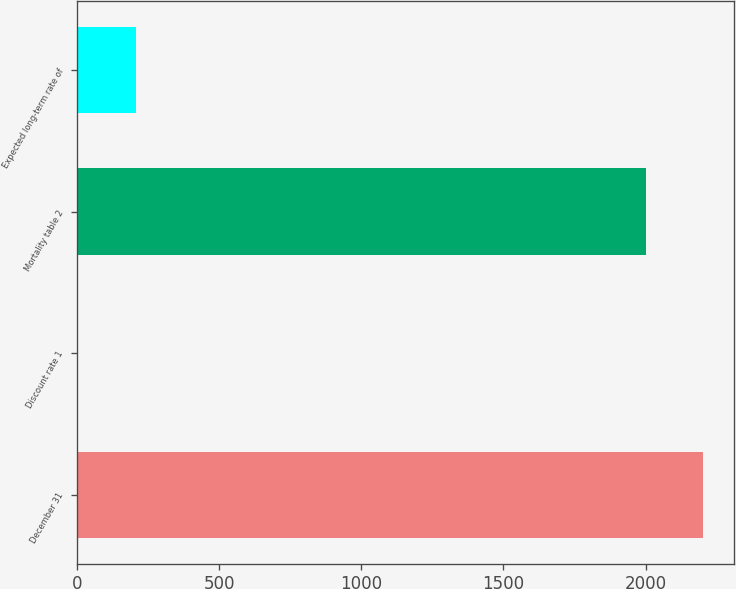Convert chart. <chart><loc_0><loc_0><loc_500><loc_500><bar_chart><fcel>December 31<fcel>Discount rate 1<fcel>Mortality table 2<fcel>Expected long-term rate of<nl><fcel>2200.81<fcel>4.9<fcel>2000<fcel>205.71<nl></chart> 